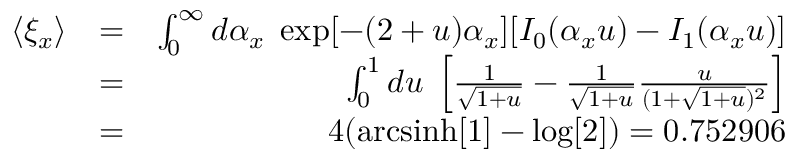<formula> <loc_0><loc_0><loc_500><loc_500>\begin{array} { r l r } { \langle \xi _ { x } \rangle } & { = } & { \int _ { 0 } ^ { \infty } d \alpha _ { x } \, \exp [ - ( 2 + u ) \alpha _ { x } ] [ I _ { 0 } ( \alpha _ { x } u ) - I _ { 1 } ( \alpha _ { x } u ) ] } \\ & { = } & { \int _ { 0 } ^ { 1 } d u \, \left [ \frac { 1 } { \sqrt { 1 + u } } - \frac { 1 } { \sqrt { 1 + u } } \frac { u } { ( 1 + \sqrt { 1 + u } ) ^ { 2 } } \right ] } \\ & { = } & { 4 ( a r c \sinh [ 1 ] - \log [ 2 ] ) = 0 . 7 5 2 9 0 6 } \end{array}</formula> 